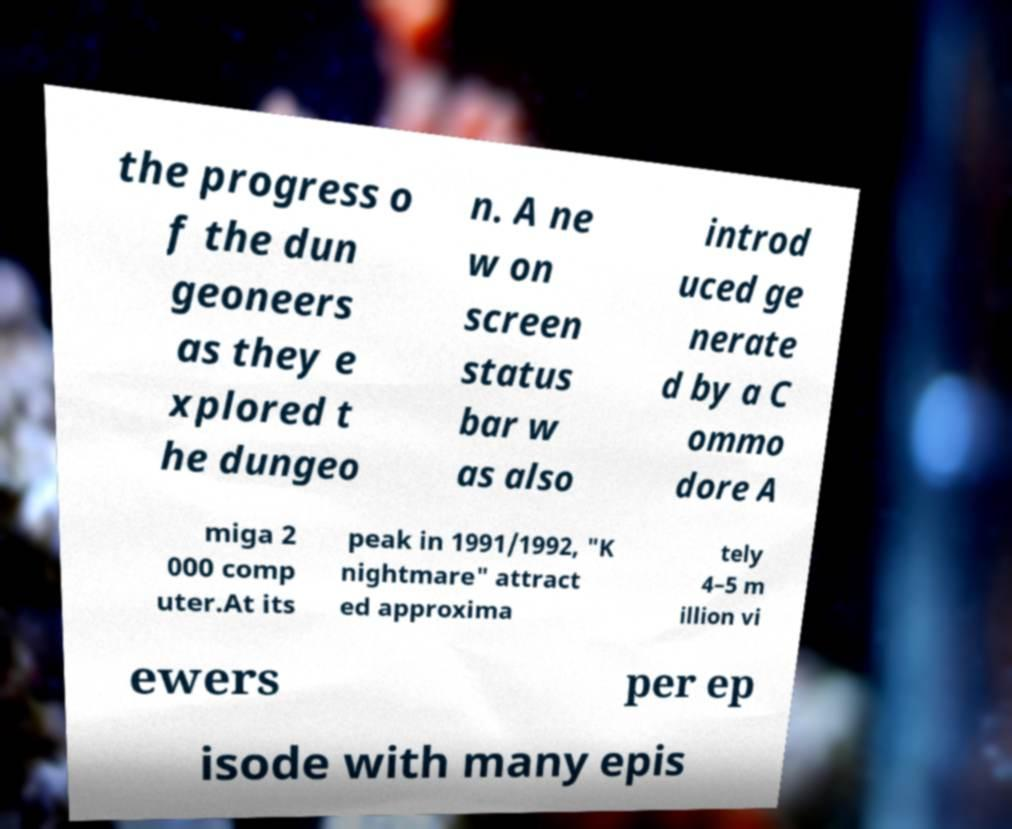Could you assist in decoding the text presented in this image and type it out clearly? the progress o f the dun geoneers as they e xplored t he dungeo n. A ne w on screen status bar w as also introd uced ge nerate d by a C ommo dore A miga 2 000 comp uter.At its peak in 1991/1992, "K nightmare" attract ed approxima tely 4–5 m illion vi ewers per ep isode with many epis 